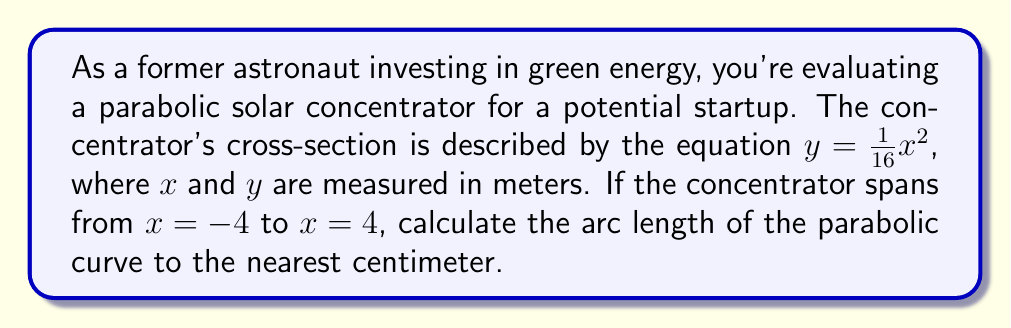Could you help me with this problem? To calculate the arc length of a parabolic curve, we'll use the arc length formula for a function $y = f(x)$:

$$L = \int_{a}^{b} \sqrt{1 + \left(\frac{dy}{dx}\right)^2} dx$$

Step 1: Find $\frac{dy}{dx}$
$y = \frac{1}{16}x^2$
$\frac{dy}{dx} = \frac{1}{8}x$

Step 2: Substitute into the arc length formula
$$L = \int_{-4}^{4} \sqrt{1 + \left(\frac{1}{8}x\right)^2} dx$$

Step 3: Simplify the integrand
$$L = \int_{-4}^{4} \sqrt{1 + \frac{1}{64}x^2} dx$$

Step 4: This integral doesn't have an elementary antiderivative, so we'll use the substitution $x = 8\sinh(t)$:

$dx = 8\cosh(t)dt$
When $x = -4$, $t = \sinh^{-1}(-\frac{1}{2})$
When $x = 4$, $t = \sinh^{-1}(\frac{1}{2})$

$$L = \int_{\sinh^{-1}(-\frac{1}{2})}^{\sinh^{-1}(\frac{1}{2})} \sqrt{1 + \sinh^2(t)} \cdot 8\cosh(t)dt$$

Step 5: Simplify using the identity $1 + \sinh^2(t) = \cosh^2(t)$

$$L = 8\int_{\sinh^{-1}(-\frac{1}{2})}^{\sinh^{-1}(\frac{1}{2})} \cosh^2(t)dt$$

Step 6: Use the identity $\cosh^2(t) = \frac{1}{2}(\cosh(2t) + 1)$

$$L = 4\int_{\sinh^{-1}(-\frac{1}{2})}^{\sinh^{-1}(\frac{1}{2})} (\cosh(2t) + 1)dt$$

Step 7: Integrate
$$L = 4\left[\frac{1}{2}\sinh(2t) + t\right]_{\sinh^{-1}(-\frac{1}{2})}^{\sinh^{-1}(\frac{1}{2})}$$

Step 8: Evaluate the integral
$$L = 4\left[\frac{1}{2}\sinh(2\sinh^{-1}(\frac{1}{2})) + \sinh^{-1}(\frac{1}{2}) - \left(\frac{1}{2}\sinh(2\sinh^{-1}(-\frac{1}{2})) + \sinh^{-1}(-\frac{1}{2})\right)\right]$$

Step 9: Simplify using $\sinh(2\sinh^{-1}(x)) = 2x\sqrt{1+x^2}$
$$L = 4\left[\frac{1}{2}(2\cdot\frac{1}{2}\sqrt{1+(\frac{1}{2})^2}) + \sinh^{-1}(\frac{1}{2}) - \left(\frac{1}{2}(2\cdot(-\frac{1}{2})\sqrt{1+(-\frac{1}{2})^2}) + (-\sinh^{-1}(\frac{1}{2}))\right)\right]$$

Step 10: Calculate the final result
$$L \approx 8.3219 \text{ meters}$$

Rounding to the nearest centimeter gives 8.32 meters.
Answer: 8.32 m 